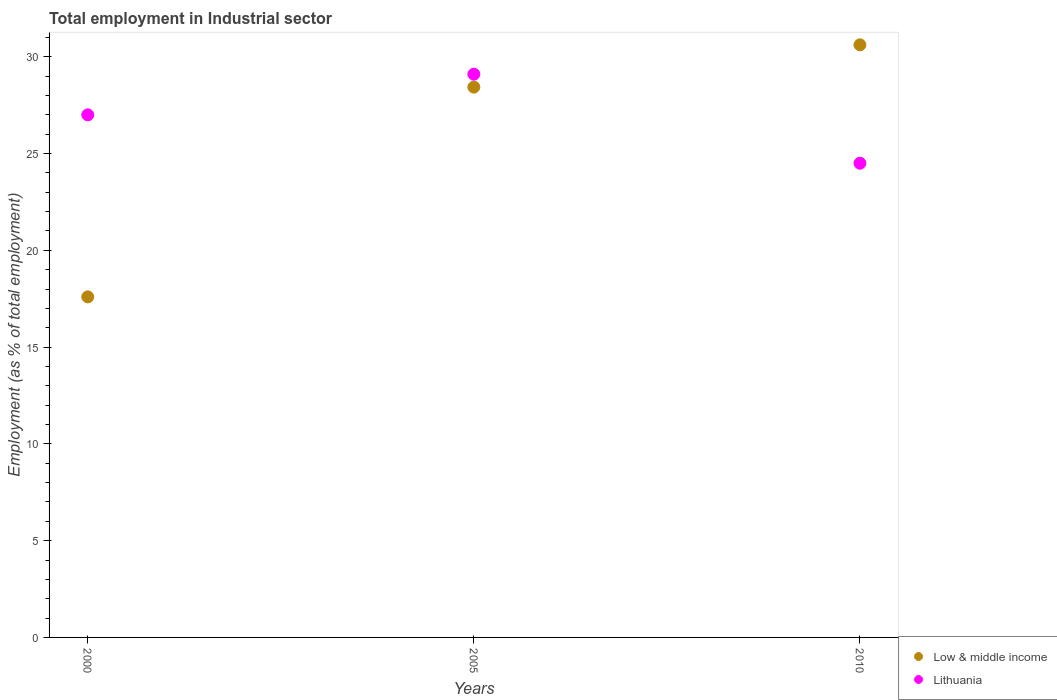How many different coloured dotlines are there?
Make the answer very short. 2. What is the employment in industrial sector in Lithuania in 2000?
Provide a succinct answer. 27. Across all years, what is the maximum employment in industrial sector in Lithuania?
Your answer should be compact. 29.1. Across all years, what is the minimum employment in industrial sector in Low & middle income?
Keep it short and to the point. 17.59. In which year was the employment in industrial sector in Lithuania minimum?
Your response must be concise. 2010. What is the total employment in industrial sector in Lithuania in the graph?
Provide a short and direct response. 80.6. What is the difference between the employment in industrial sector in Low & middle income in 2000 and that in 2005?
Your answer should be very brief. -10.84. What is the difference between the employment in industrial sector in Lithuania in 2000 and the employment in industrial sector in Low & middle income in 2010?
Your answer should be compact. -3.62. What is the average employment in industrial sector in Low & middle income per year?
Offer a very short reply. 25.55. In the year 2005, what is the difference between the employment in industrial sector in Low & middle income and employment in industrial sector in Lithuania?
Your response must be concise. -0.67. What is the ratio of the employment in industrial sector in Lithuania in 2000 to that in 2010?
Make the answer very short. 1.1. Is the employment in industrial sector in Lithuania in 2000 less than that in 2010?
Your answer should be very brief. No. What is the difference between the highest and the second highest employment in industrial sector in Lithuania?
Provide a short and direct response. 2.1. What is the difference between the highest and the lowest employment in industrial sector in Low & middle income?
Provide a short and direct response. 13.02. Is the sum of the employment in industrial sector in Lithuania in 2000 and 2005 greater than the maximum employment in industrial sector in Low & middle income across all years?
Give a very brief answer. Yes. Does the employment in industrial sector in Low & middle income monotonically increase over the years?
Provide a succinct answer. Yes. Is the employment in industrial sector in Low & middle income strictly greater than the employment in industrial sector in Lithuania over the years?
Your answer should be compact. No. Is the employment in industrial sector in Lithuania strictly less than the employment in industrial sector in Low & middle income over the years?
Give a very brief answer. No. Are the values on the major ticks of Y-axis written in scientific E-notation?
Your answer should be compact. No. Does the graph contain grids?
Make the answer very short. No. Where does the legend appear in the graph?
Give a very brief answer. Bottom right. How are the legend labels stacked?
Provide a short and direct response. Vertical. What is the title of the graph?
Make the answer very short. Total employment in Industrial sector. What is the label or title of the X-axis?
Provide a succinct answer. Years. What is the label or title of the Y-axis?
Give a very brief answer. Employment (as % of total employment). What is the Employment (as % of total employment) of Low & middle income in 2000?
Offer a terse response. 17.59. What is the Employment (as % of total employment) in Lithuania in 2000?
Your answer should be compact. 27. What is the Employment (as % of total employment) in Low & middle income in 2005?
Provide a short and direct response. 28.43. What is the Employment (as % of total employment) in Lithuania in 2005?
Your answer should be compact. 29.1. What is the Employment (as % of total employment) of Low & middle income in 2010?
Your answer should be very brief. 30.62. What is the Employment (as % of total employment) of Lithuania in 2010?
Make the answer very short. 24.5. Across all years, what is the maximum Employment (as % of total employment) in Low & middle income?
Ensure brevity in your answer.  30.62. Across all years, what is the maximum Employment (as % of total employment) of Lithuania?
Make the answer very short. 29.1. Across all years, what is the minimum Employment (as % of total employment) of Low & middle income?
Your answer should be very brief. 17.59. What is the total Employment (as % of total employment) in Low & middle income in the graph?
Your answer should be very brief. 76.64. What is the total Employment (as % of total employment) of Lithuania in the graph?
Offer a very short reply. 80.6. What is the difference between the Employment (as % of total employment) in Low & middle income in 2000 and that in 2005?
Offer a terse response. -10.84. What is the difference between the Employment (as % of total employment) in Low & middle income in 2000 and that in 2010?
Provide a succinct answer. -13.02. What is the difference between the Employment (as % of total employment) of Lithuania in 2000 and that in 2010?
Your response must be concise. 2.5. What is the difference between the Employment (as % of total employment) of Low & middle income in 2005 and that in 2010?
Offer a very short reply. -2.18. What is the difference between the Employment (as % of total employment) in Low & middle income in 2000 and the Employment (as % of total employment) in Lithuania in 2005?
Offer a terse response. -11.51. What is the difference between the Employment (as % of total employment) of Low & middle income in 2000 and the Employment (as % of total employment) of Lithuania in 2010?
Provide a short and direct response. -6.91. What is the difference between the Employment (as % of total employment) in Low & middle income in 2005 and the Employment (as % of total employment) in Lithuania in 2010?
Ensure brevity in your answer.  3.93. What is the average Employment (as % of total employment) of Low & middle income per year?
Offer a very short reply. 25.55. What is the average Employment (as % of total employment) in Lithuania per year?
Give a very brief answer. 26.87. In the year 2000, what is the difference between the Employment (as % of total employment) of Low & middle income and Employment (as % of total employment) of Lithuania?
Your response must be concise. -9.41. In the year 2005, what is the difference between the Employment (as % of total employment) in Low & middle income and Employment (as % of total employment) in Lithuania?
Offer a terse response. -0.67. In the year 2010, what is the difference between the Employment (as % of total employment) of Low & middle income and Employment (as % of total employment) of Lithuania?
Offer a terse response. 6.12. What is the ratio of the Employment (as % of total employment) in Low & middle income in 2000 to that in 2005?
Provide a succinct answer. 0.62. What is the ratio of the Employment (as % of total employment) in Lithuania in 2000 to that in 2005?
Your answer should be very brief. 0.93. What is the ratio of the Employment (as % of total employment) of Low & middle income in 2000 to that in 2010?
Your answer should be compact. 0.57. What is the ratio of the Employment (as % of total employment) of Lithuania in 2000 to that in 2010?
Your response must be concise. 1.1. What is the ratio of the Employment (as % of total employment) of Low & middle income in 2005 to that in 2010?
Provide a succinct answer. 0.93. What is the ratio of the Employment (as % of total employment) of Lithuania in 2005 to that in 2010?
Provide a succinct answer. 1.19. What is the difference between the highest and the second highest Employment (as % of total employment) in Low & middle income?
Your answer should be compact. 2.18. What is the difference between the highest and the second highest Employment (as % of total employment) in Lithuania?
Give a very brief answer. 2.1. What is the difference between the highest and the lowest Employment (as % of total employment) of Low & middle income?
Your answer should be compact. 13.02. 